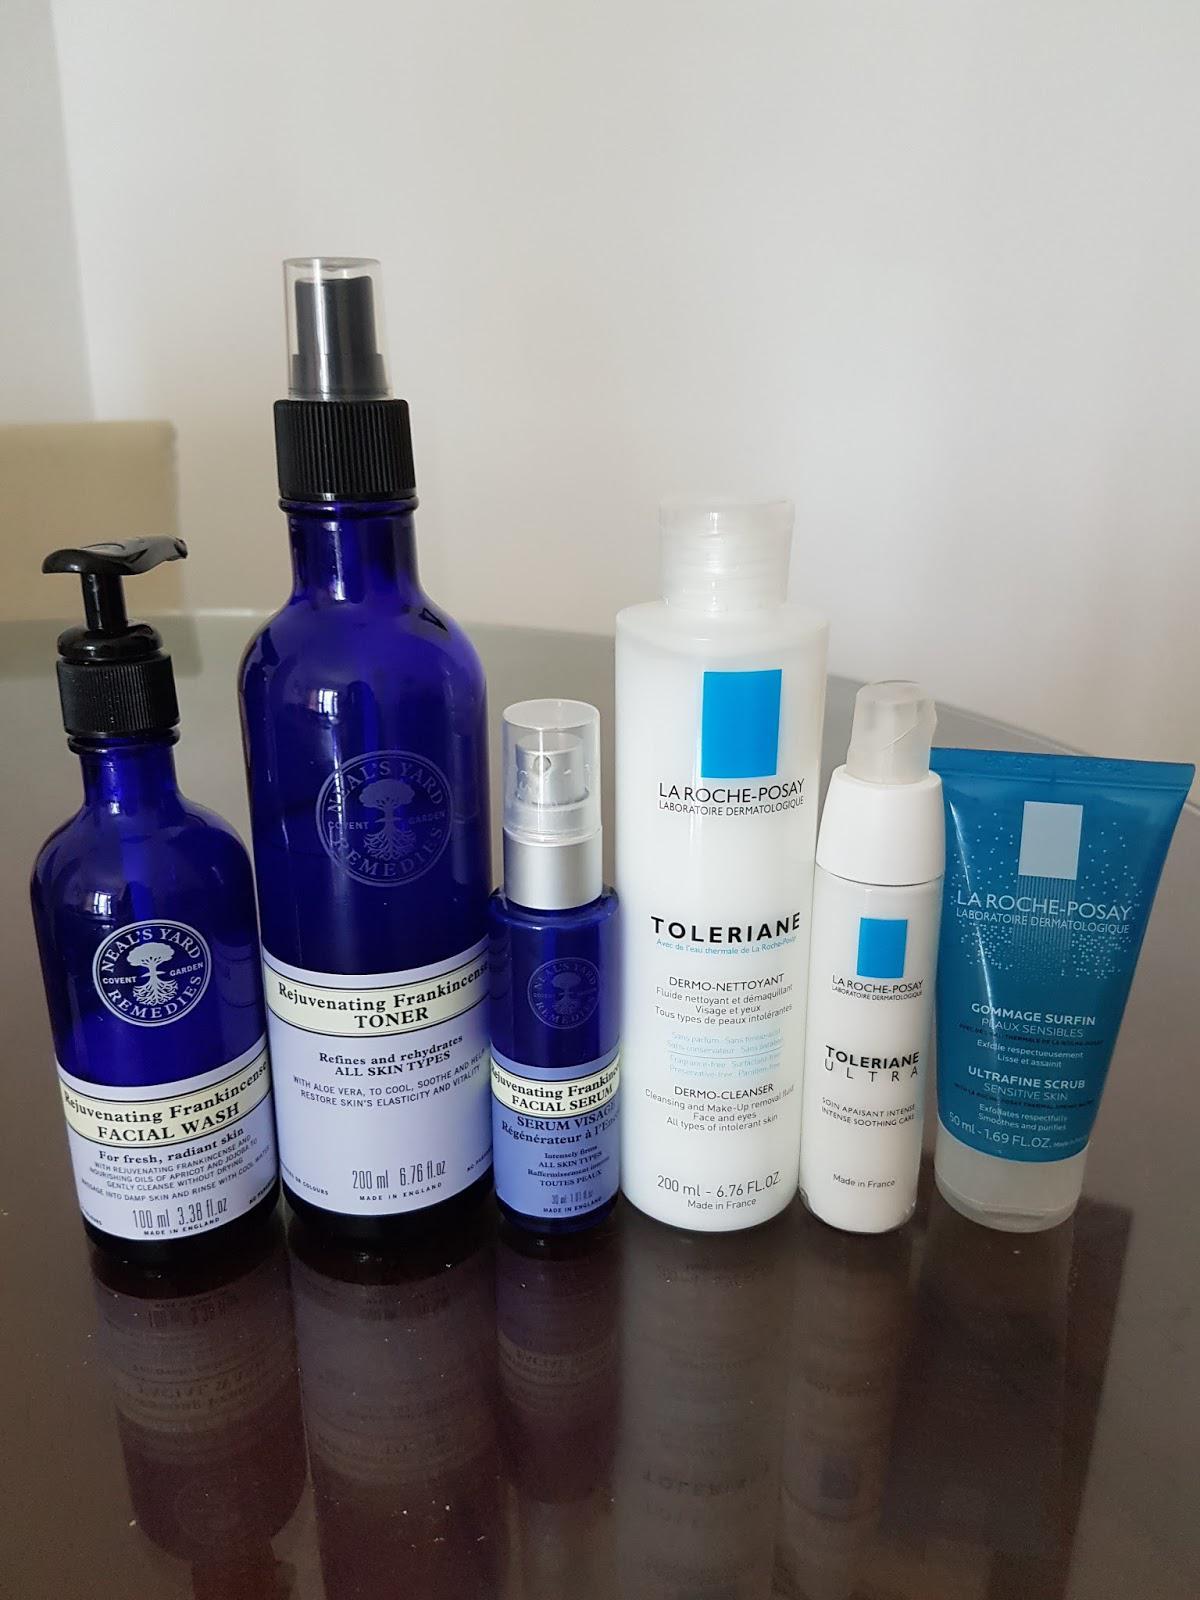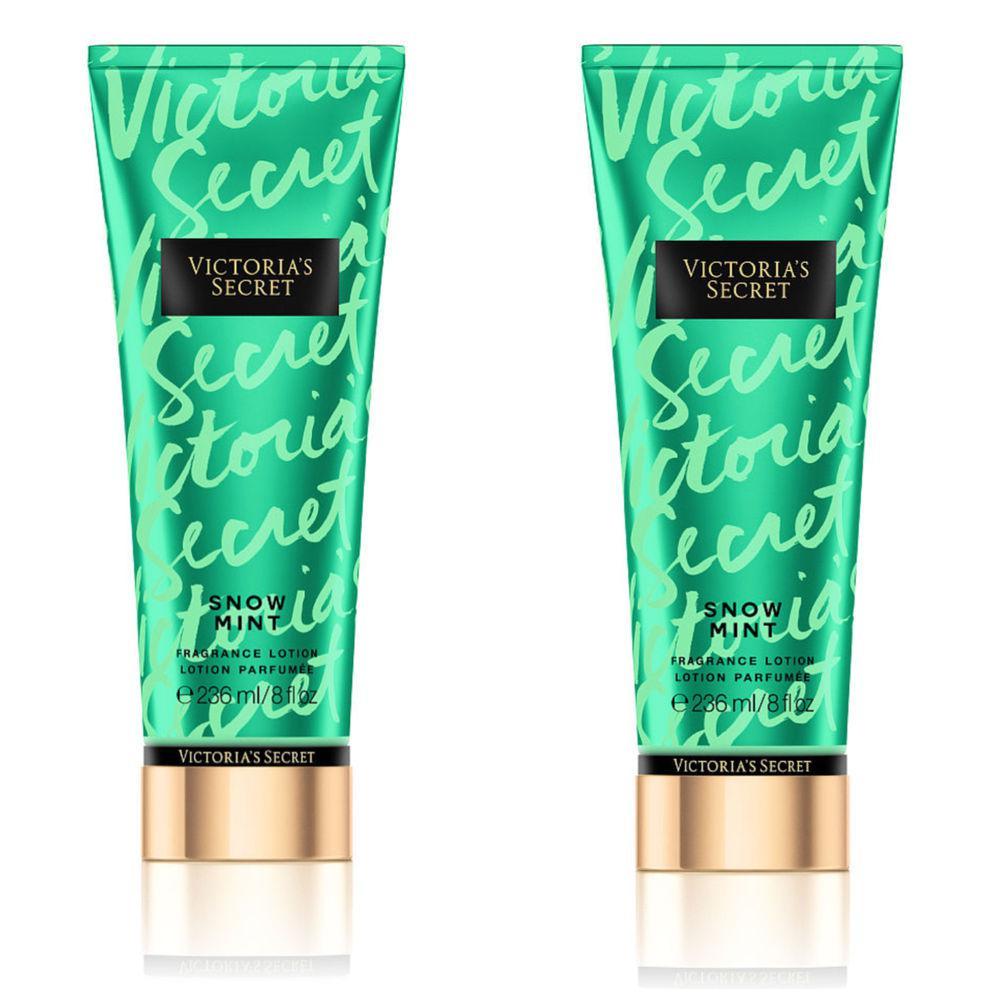The first image is the image on the left, the second image is the image on the right. Assess this claim about the two images: "A short wide pump bottle of lotion is shown with one other product in one image and with two other products in the other image.". Correct or not? Answer yes or no. No. The first image is the image on the left, the second image is the image on the right. Analyze the images presented: Is the assertion "The left image shows exactly three products, each in a different packaging format." valid? Answer yes or no. No. 